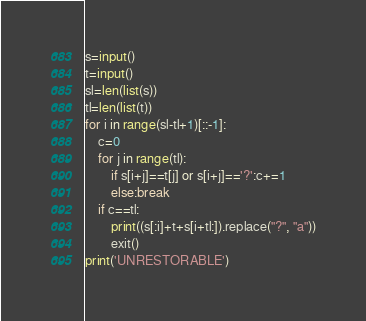Convert code to text. <code><loc_0><loc_0><loc_500><loc_500><_Python_>s=input()
t=input()
sl=len(list(s))
tl=len(list(t))
for i in range(sl-tl+1)[::-1]:
    c=0
    for j in range(tl):
        if s[i+j]==t[j] or s[i+j]=='?':c+=1
        else:break
    if c==tl:
        print((s[:i]+t+s[i+tl:]).replace("?", "a"))
        exit()
print('UNRESTORABLE')</code> 